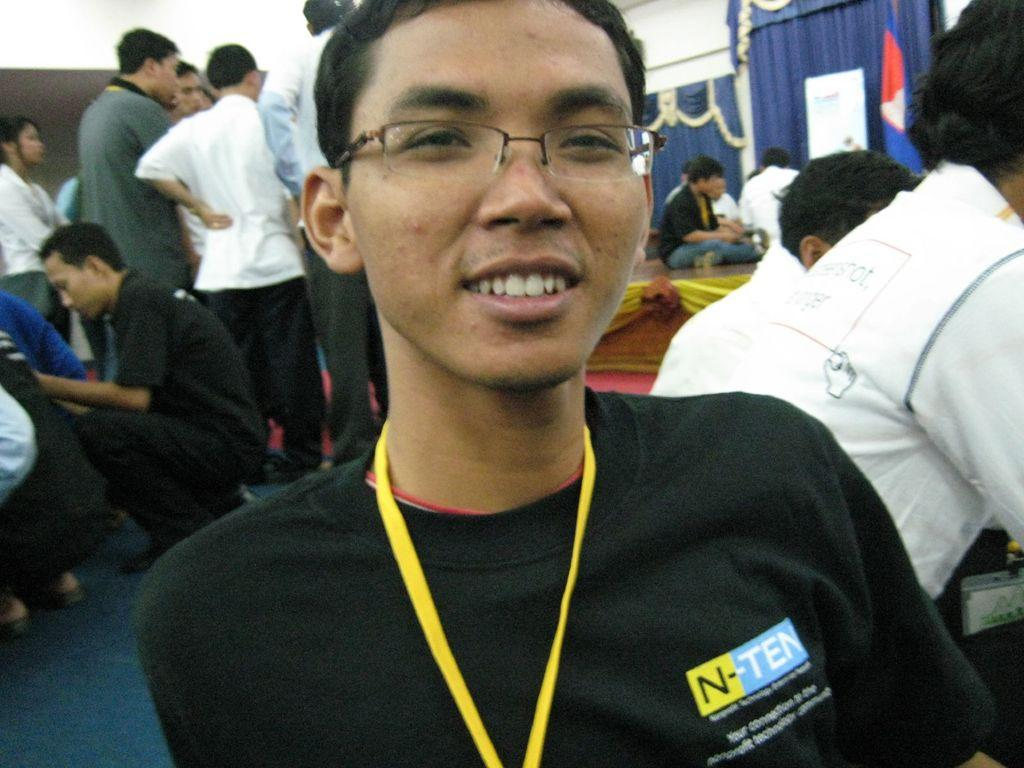What are the people in the image doing? There are people sitting and standing in the image. Can you describe the curtains in the image? There are blue door curtains at the backside of the image. What type of pets are visible in the image? There are no pets visible in the image. Are the people in the image driving a vehicle? There is no indication of a vehicle or driving in the image. 